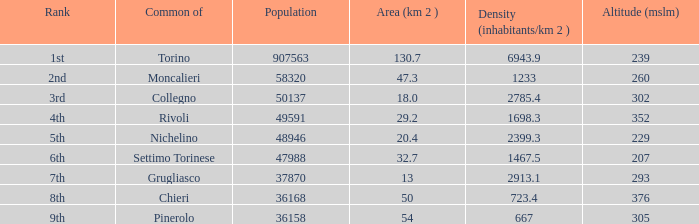How many heights does the common with an area of 13 1.0. 